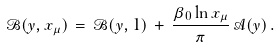<formula> <loc_0><loc_0><loc_500><loc_500>\mathcal { B } ( y , x _ { \mu } ) \, = \, \mathcal { B } ( y , 1 ) \, + \, \frac { \beta _ { 0 } \ln x _ { \mu } } { \pi } \, \mathcal { A } ( y ) \, .</formula> 